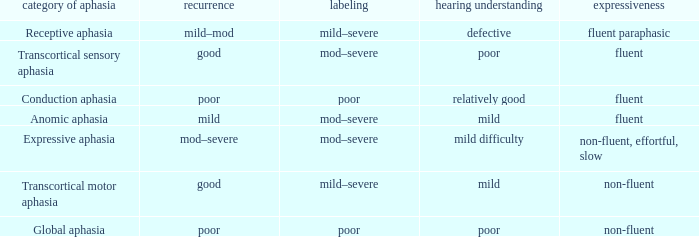Name the fluency for transcortical sensory aphasia Fluent. 